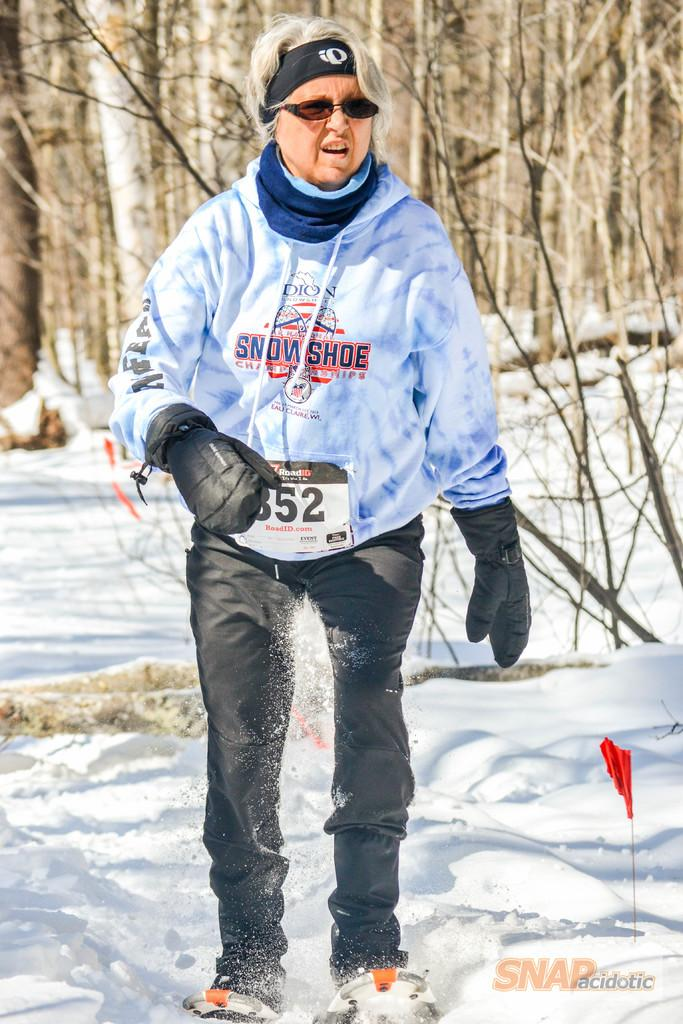Who is present in the image? There is a woman in the image. What is the woman standing on? The woman is standing on the snow. What can be seen on the right side of the image? There is a flag on the right side of the image. What is visible in the background of the image? There are trees in the background of the image. What type of music is the band playing in the background of the image? There is no band present in the image, so it is not possible to determine what type of music they might be playing. 